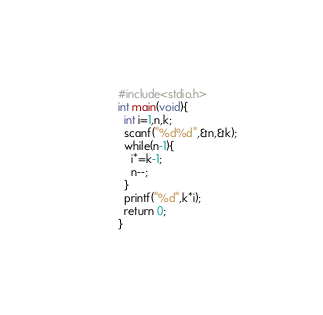<code> <loc_0><loc_0><loc_500><loc_500><_C_>#include<stdio.h>
int main(void){
  int i=1,n,k;
  scanf("%d%d",&n,&k);
  while(n-1){
    i*=k-1;
    n--;
  }
  printf("%d",k*i);
  return 0;
}</code> 